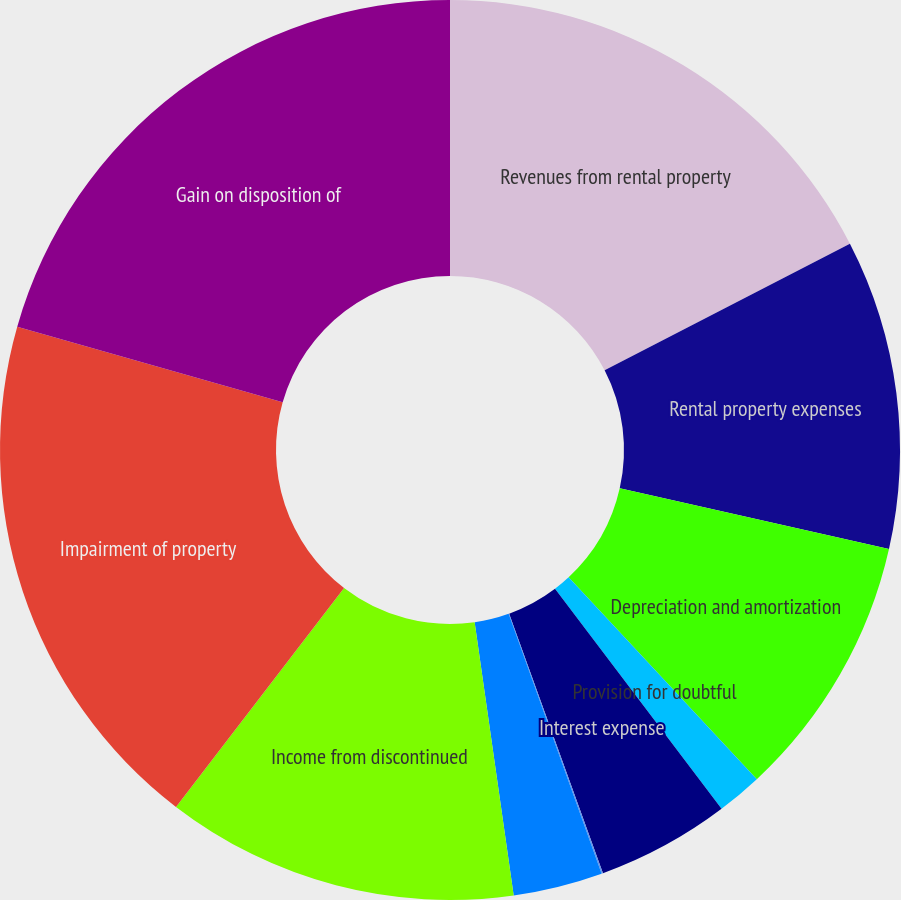Convert chart to OTSL. <chart><loc_0><loc_0><loc_500><loc_500><pie_chart><fcel>Revenues from rental property<fcel>Rental property expenses<fcel>Depreciation and amortization<fcel>Provision for doubtful<fcel>Interest expense<fcel>Income from other real estate<fcel>Other expense net<fcel>Income from discontinued<fcel>Impairment of property<fcel>Gain on disposition of<nl><fcel>17.42%<fcel>11.11%<fcel>9.53%<fcel>1.63%<fcel>4.79%<fcel>0.05%<fcel>3.21%<fcel>12.68%<fcel>19.0%<fcel>20.58%<nl></chart> 